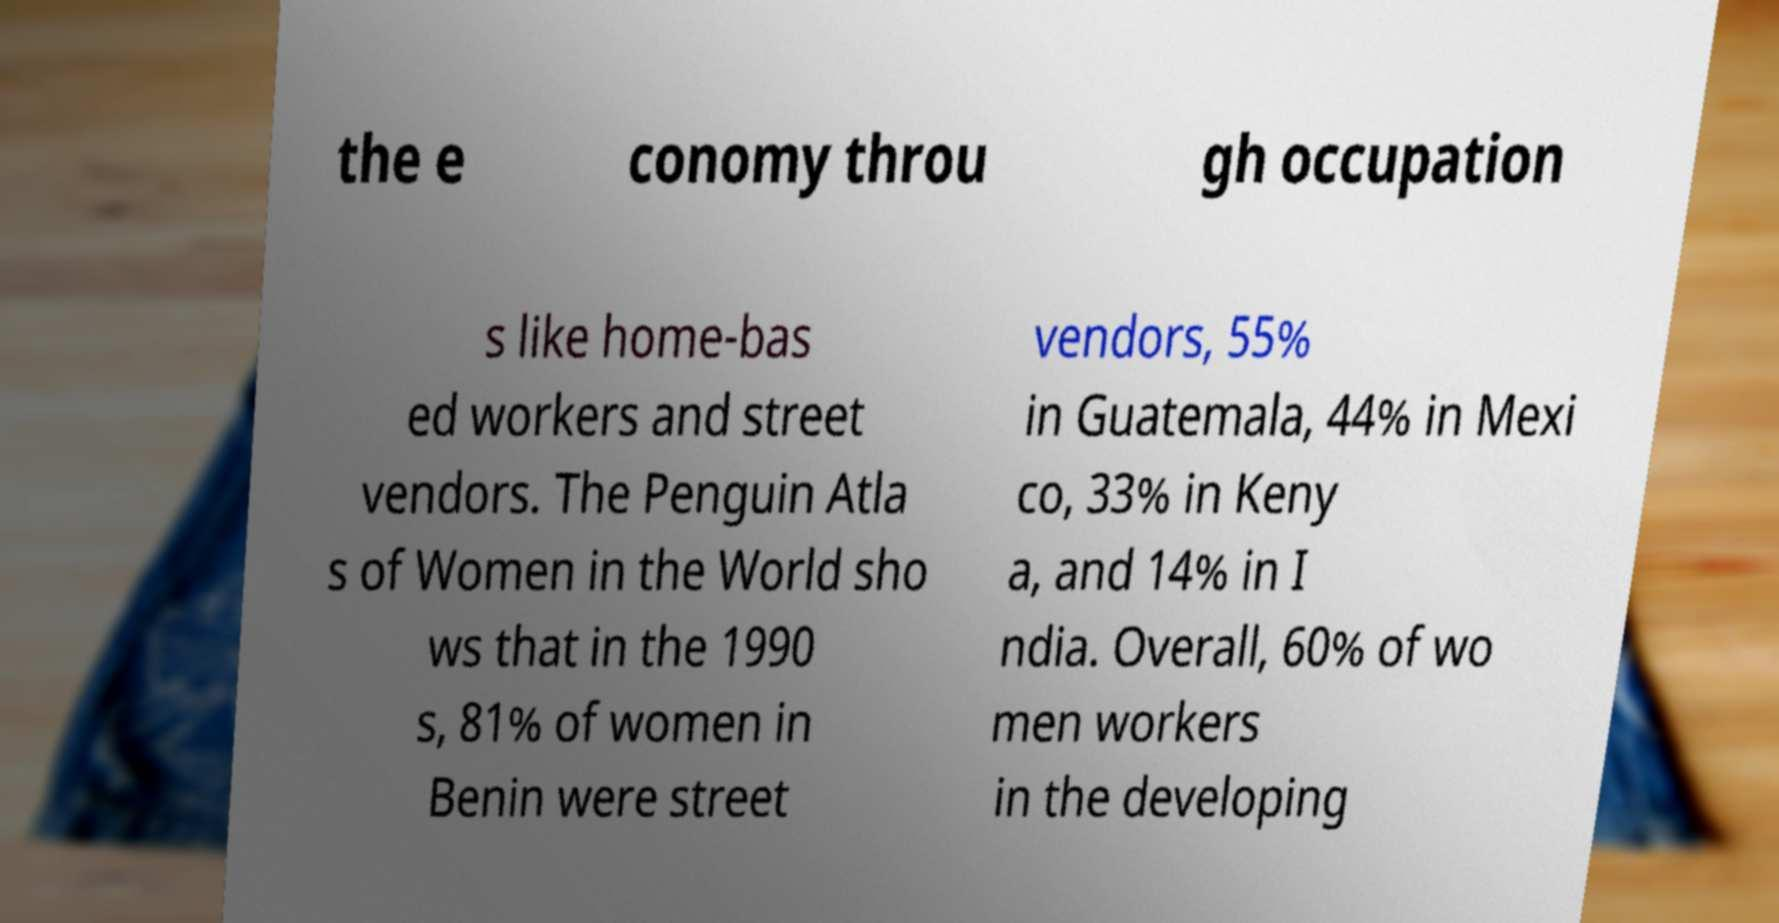There's text embedded in this image that I need extracted. Can you transcribe it verbatim? the e conomy throu gh occupation s like home-bas ed workers and street vendors. The Penguin Atla s of Women in the World sho ws that in the 1990 s, 81% of women in Benin were street vendors, 55% in Guatemala, 44% in Mexi co, 33% in Keny a, and 14% in I ndia. Overall, 60% of wo men workers in the developing 